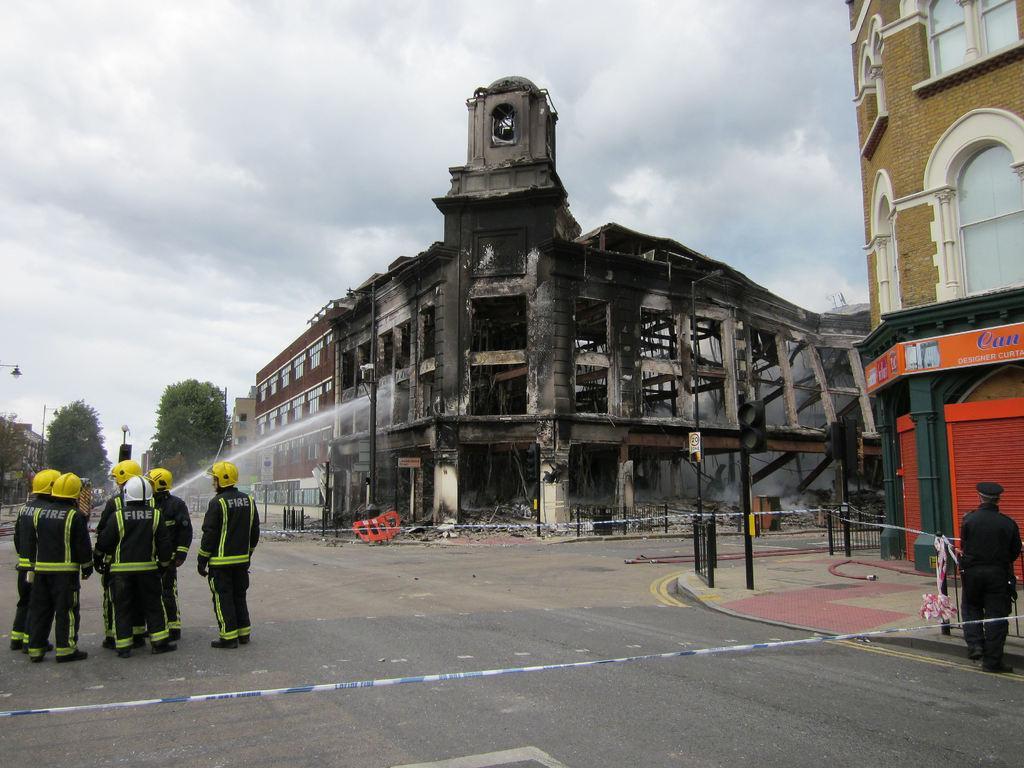Can you describe this image briefly? In this image I can see few buildings,stores,traffic signal,fencing,poles,trees and light poles. I can see few people are standing. The sky is in white and blue color. 